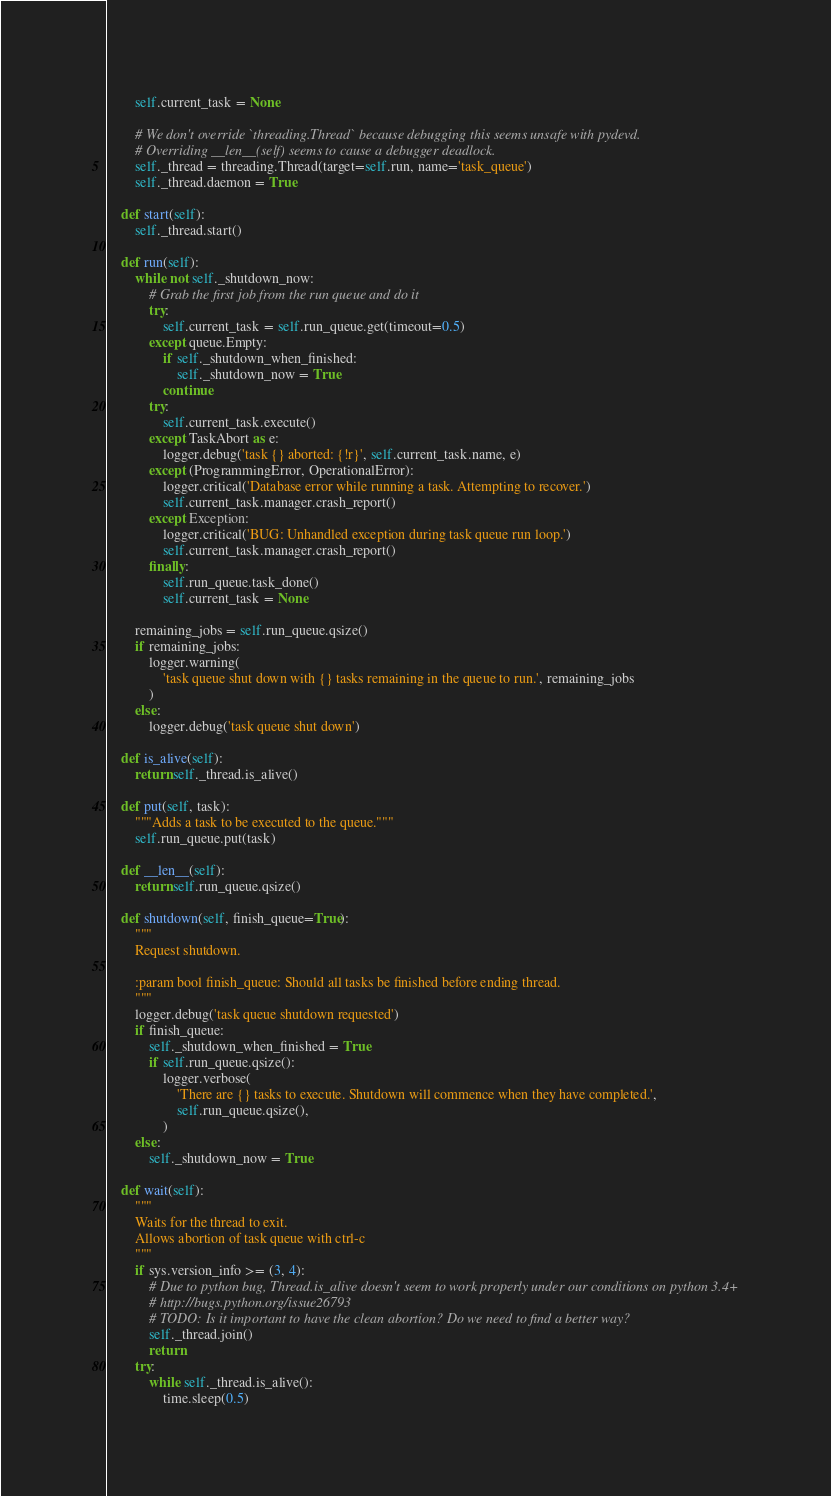Convert code to text. <code><loc_0><loc_0><loc_500><loc_500><_Python_>        self.current_task = None

        # We don't override `threading.Thread` because debugging this seems unsafe with pydevd.
        # Overriding __len__(self) seems to cause a debugger deadlock.
        self._thread = threading.Thread(target=self.run, name='task_queue')
        self._thread.daemon = True

    def start(self):
        self._thread.start()

    def run(self):
        while not self._shutdown_now:
            # Grab the first job from the run queue and do it
            try:
                self.current_task = self.run_queue.get(timeout=0.5)
            except queue.Empty:
                if self._shutdown_when_finished:
                    self._shutdown_now = True
                continue
            try:
                self.current_task.execute()
            except TaskAbort as e:
                logger.debug('task {} aborted: {!r}', self.current_task.name, e)
            except (ProgrammingError, OperationalError):
                logger.critical('Database error while running a task. Attempting to recover.')
                self.current_task.manager.crash_report()
            except Exception:
                logger.critical('BUG: Unhandled exception during task queue run loop.')
                self.current_task.manager.crash_report()
            finally:
                self.run_queue.task_done()
                self.current_task = None

        remaining_jobs = self.run_queue.qsize()
        if remaining_jobs:
            logger.warning(
                'task queue shut down with {} tasks remaining in the queue to run.', remaining_jobs
            )
        else:
            logger.debug('task queue shut down')

    def is_alive(self):
        return self._thread.is_alive()

    def put(self, task):
        """Adds a task to be executed to the queue."""
        self.run_queue.put(task)

    def __len__(self):
        return self.run_queue.qsize()

    def shutdown(self, finish_queue=True):
        """
        Request shutdown.

        :param bool finish_queue: Should all tasks be finished before ending thread.
        """
        logger.debug('task queue shutdown requested')
        if finish_queue:
            self._shutdown_when_finished = True
            if self.run_queue.qsize():
                logger.verbose(
                    'There are {} tasks to execute. Shutdown will commence when they have completed.',
                    self.run_queue.qsize(),
                )
        else:
            self._shutdown_now = True

    def wait(self):
        """
        Waits for the thread to exit.
        Allows abortion of task queue with ctrl-c
        """
        if sys.version_info >= (3, 4):
            # Due to python bug, Thread.is_alive doesn't seem to work properly under our conditions on python 3.4+
            # http://bugs.python.org/issue26793
            # TODO: Is it important to have the clean abortion? Do we need to find a better way?
            self._thread.join()
            return
        try:
            while self._thread.is_alive():
                time.sleep(0.5)</code> 